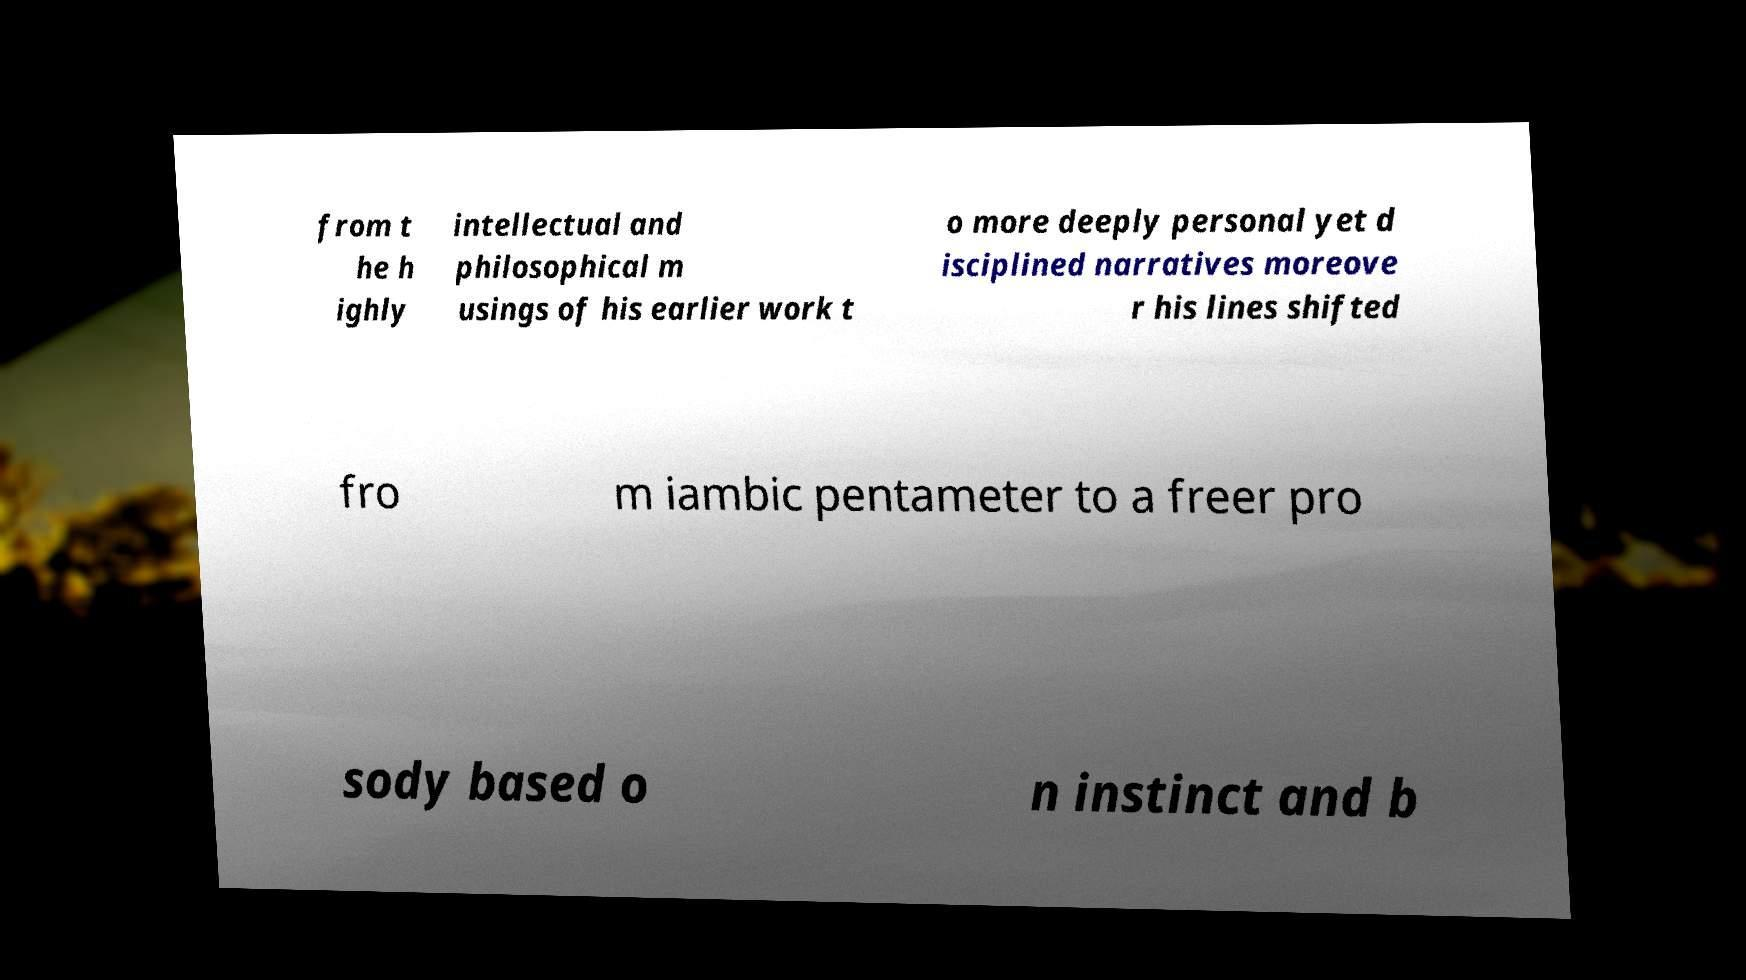Please read and relay the text visible in this image. What does it say? from t he h ighly intellectual and philosophical m usings of his earlier work t o more deeply personal yet d isciplined narratives moreove r his lines shifted fro m iambic pentameter to a freer pro sody based o n instinct and b 